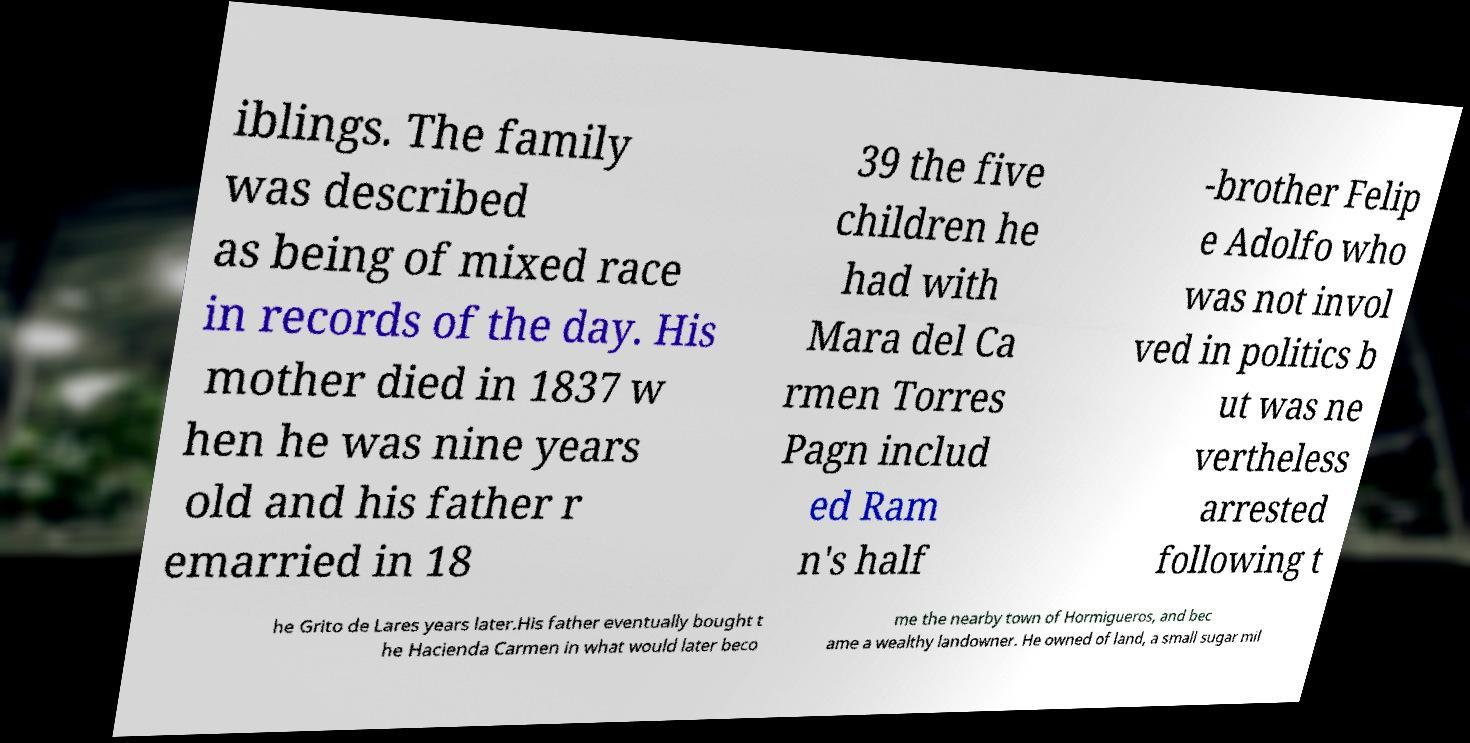Please identify and transcribe the text found in this image. iblings. The family was described as being of mixed race in records of the day. His mother died in 1837 w hen he was nine years old and his father r emarried in 18 39 the five children he had with Mara del Ca rmen Torres Pagn includ ed Ram n's half -brother Felip e Adolfo who was not invol ved in politics b ut was ne vertheless arrested following t he Grito de Lares years later.His father eventually bought t he Hacienda Carmen in what would later beco me the nearby town of Hormigueros, and bec ame a wealthy landowner. He owned of land, a small sugar mil 